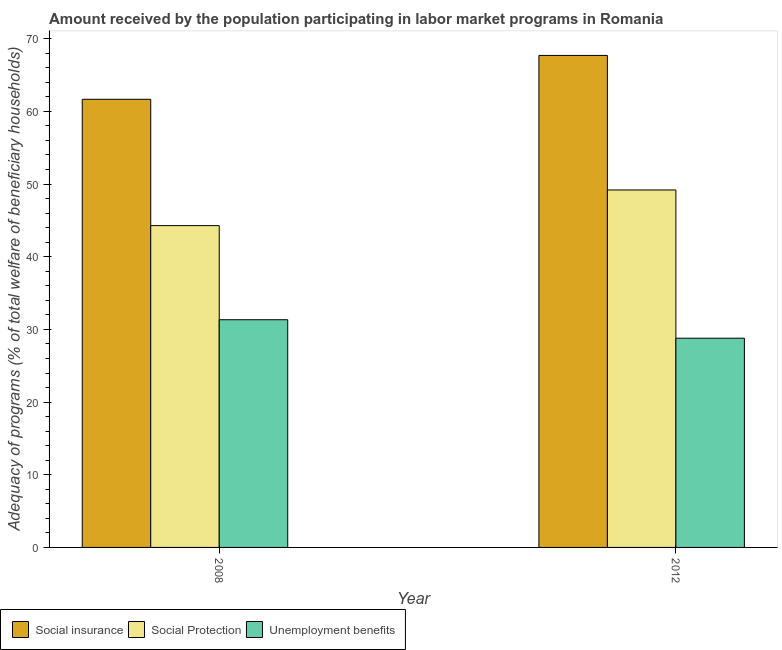Are the number of bars per tick equal to the number of legend labels?
Make the answer very short. Yes. Are the number of bars on each tick of the X-axis equal?
Your answer should be compact. Yes. What is the label of the 1st group of bars from the left?
Offer a terse response. 2008. In how many cases, is the number of bars for a given year not equal to the number of legend labels?
Make the answer very short. 0. What is the amount received by the population participating in unemployment benefits programs in 2008?
Give a very brief answer. 31.33. Across all years, what is the maximum amount received by the population participating in unemployment benefits programs?
Offer a very short reply. 31.33. Across all years, what is the minimum amount received by the population participating in social protection programs?
Offer a terse response. 44.28. In which year was the amount received by the population participating in unemployment benefits programs maximum?
Make the answer very short. 2008. In which year was the amount received by the population participating in social insurance programs minimum?
Keep it short and to the point. 2008. What is the total amount received by the population participating in social insurance programs in the graph?
Offer a terse response. 129.36. What is the difference between the amount received by the population participating in social protection programs in 2008 and that in 2012?
Make the answer very short. -4.91. What is the difference between the amount received by the population participating in social insurance programs in 2008 and the amount received by the population participating in social protection programs in 2012?
Offer a very short reply. -6.04. What is the average amount received by the population participating in social insurance programs per year?
Give a very brief answer. 64.68. What is the ratio of the amount received by the population participating in social insurance programs in 2008 to that in 2012?
Offer a very short reply. 0.91. Is the amount received by the population participating in unemployment benefits programs in 2008 less than that in 2012?
Your answer should be very brief. No. What does the 2nd bar from the left in 2012 represents?
Your answer should be compact. Social Protection. What does the 2nd bar from the right in 2008 represents?
Your answer should be very brief. Social Protection. Is it the case that in every year, the sum of the amount received by the population participating in social insurance programs and amount received by the population participating in social protection programs is greater than the amount received by the population participating in unemployment benefits programs?
Make the answer very short. Yes. Does the graph contain grids?
Make the answer very short. No. Where does the legend appear in the graph?
Ensure brevity in your answer.  Bottom left. How many legend labels are there?
Make the answer very short. 3. What is the title of the graph?
Offer a very short reply. Amount received by the population participating in labor market programs in Romania. What is the label or title of the X-axis?
Your answer should be compact. Year. What is the label or title of the Y-axis?
Give a very brief answer. Adequacy of programs (% of total welfare of beneficiary households). What is the Adequacy of programs (% of total welfare of beneficiary households) in Social insurance in 2008?
Ensure brevity in your answer.  61.66. What is the Adequacy of programs (% of total welfare of beneficiary households) in Social Protection in 2008?
Your answer should be very brief. 44.28. What is the Adequacy of programs (% of total welfare of beneficiary households) of Unemployment benefits in 2008?
Provide a short and direct response. 31.33. What is the Adequacy of programs (% of total welfare of beneficiary households) in Social insurance in 2012?
Provide a short and direct response. 67.7. What is the Adequacy of programs (% of total welfare of beneficiary households) of Social Protection in 2012?
Keep it short and to the point. 49.18. What is the Adequacy of programs (% of total welfare of beneficiary households) in Unemployment benefits in 2012?
Ensure brevity in your answer.  28.79. Across all years, what is the maximum Adequacy of programs (% of total welfare of beneficiary households) in Social insurance?
Your answer should be compact. 67.7. Across all years, what is the maximum Adequacy of programs (% of total welfare of beneficiary households) in Social Protection?
Ensure brevity in your answer.  49.18. Across all years, what is the maximum Adequacy of programs (% of total welfare of beneficiary households) of Unemployment benefits?
Your answer should be compact. 31.33. Across all years, what is the minimum Adequacy of programs (% of total welfare of beneficiary households) of Social insurance?
Give a very brief answer. 61.66. Across all years, what is the minimum Adequacy of programs (% of total welfare of beneficiary households) in Social Protection?
Provide a short and direct response. 44.28. Across all years, what is the minimum Adequacy of programs (% of total welfare of beneficiary households) in Unemployment benefits?
Offer a terse response. 28.79. What is the total Adequacy of programs (% of total welfare of beneficiary households) in Social insurance in the graph?
Make the answer very short. 129.36. What is the total Adequacy of programs (% of total welfare of beneficiary households) in Social Protection in the graph?
Provide a short and direct response. 93.46. What is the total Adequacy of programs (% of total welfare of beneficiary households) of Unemployment benefits in the graph?
Your response must be concise. 60.12. What is the difference between the Adequacy of programs (% of total welfare of beneficiary households) in Social insurance in 2008 and that in 2012?
Your answer should be compact. -6.04. What is the difference between the Adequacy of programs (% of total welfare of beneficiary households) of Social Protection in 2008 and that in 2012?
Provide a succinct answer. -4.91. What is the difference between the Adequacy of programs (% of total welfare of beneficiary households) in Unemployment benefits in 2008 and that in 2012?
Offer a very short reply. 2.54. What is the difference between the Adequacy of programs (% of total welfare of beneficiary households) in Social insurance in 2008 and the Adequacy of programs (% of total welfare of beneficiary households) in Social Protection in 2012?
Offer a terse response. 12.48. What is the difference between the Adequacy of programs (% of total welfare of beneficiary households) in Social insurance in 2008 and the Adequacy of programs (% of total welfare of beneficiary households) in Unemployment benefits in 2012?
Your answer should be compact. 32.87. What is the difference between the Adequacy of programs (% of total welfare of beneficiary households) in Social Protection in 2008 and the Adequacy of programs (% of total welfare of beneficiary households) in Unemployment benefits in 2012?
Offer a very short reply. 15.49. What is the average Adequacy of programs (% of total welfare of beneficiary households) in Social insurance per year?
Ensure brevity in your answer.  64.68. What is the average Adequacy of programs (% of total welfare of beneficiary households) of Social Protection per year?
Your response must be concise. 46.73. What is the average Adequacy of programs (% of total welfare of beneficiary households) of Unemployment benefits per year?
Your response must be concise. 30.06. In the year 2008, what is the difference between the Adequacy of programs (% of total welfare of beneficiary households) in Social insurance and Adequacy of programs (% of total welfare of beneficiary households) in Social Protection?
Your response must be concise. 17.38. In the year 2008, what is the difference between the Adequacy of programs (% of total welfare of beneficiary households) in Social insurance and Adequacy of programs (% of total welfare of beneficiary households) in Unemployment benefits?
Give a very brief answer. 30.33. In the year 2008, what is the difference between the Adequacy of programs (% of total welfare of beneficiary households) of Social Protection and Adequacy of programs (% of total welfare of beneficiary households) of Unemployment benefits?
Make the answer very short. 12.95. In the year 2012, what is the difference between the Adequacy of programs (% of total welfare of beneficiary households) of Social insurance and Adequacy of programs (% of total welfare of beneficiary households) of Social Protection?
Keep it short and to the point. 18.51. In the year 2012, what is the difference between the Adequacy of programs (% of total welfare of beneficiary households) of Social insurance and Adequacy of programs (% of total welfare of beneficiary households) of Unemployment benefits?
Offer a terse response. 38.91. In the year 2012, what is the difference between the Adequacy of programs (% of total welfare of beneficiary households) of Social Protection and Adequacy of programs (% of total welfare of beneficiary households) of Unemployment benefits?
Offer a terse response. 20.4. What is the ratio of the Adequacy of programs (% of total welfare of beneficiary households) of Social insurance in 2008 to that in 2012?
Your response must be concise. 0.91. What is the ratio of the Adequacy of programs (% of total welfare of beneficiary households) of Social Protection in 2008 to that in 2012?
Keep it short and to the point. 0.9. What is the ratio of the Adequacy of programs (% of total welfare of beneficiary households) of Unemployment benefits in 2008 to that in 2012?
Your response must be concise. 1.09. What is the difference between the highest and the second highest Adequacy of programs (% of total welfare of beneficiary households) of Social insurance?
Provide a short and direct response. 6.04. What is the difference between the highest and the second highest Adequacy of programs (% of total welfare of beneficiary households) of Social Protection?
Provide a short and direct response. 4.91. What is the difference between the highest and the second highest Adequacy of programs (% of total welfare of beneficiary households) of Unemployment benefits?
Give a very brief answer. 2.54. What is the difference between the highest and the lowest Adequacy of programs (% of total welfare of beneficiary households) of Social insurance?
Ensure brevity in your answer.  6.04. What is the difference between the highest and the lowest Adequacy of programs (% of total welfare of beneficiary households) in Social Protection?
Your answer should be compact. 4.91. What is the difference between the highest and the lowest Adequacy of programs (% of total welfare of beneficiary households) in Unemployment benefits?
Ensure brevity in your answer.  2.54. 